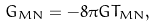<formula> <loc_0><loc_0><loc_500><loc_500>G _ { M N } = - 8 \pi G T _ { M N } ,</formula> 